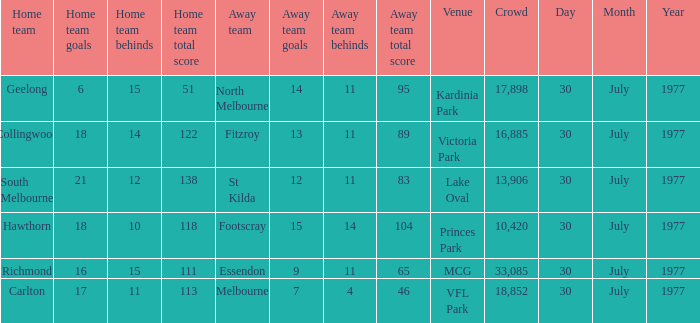What is north melbourne's score as an away side? 14.11 (95). 